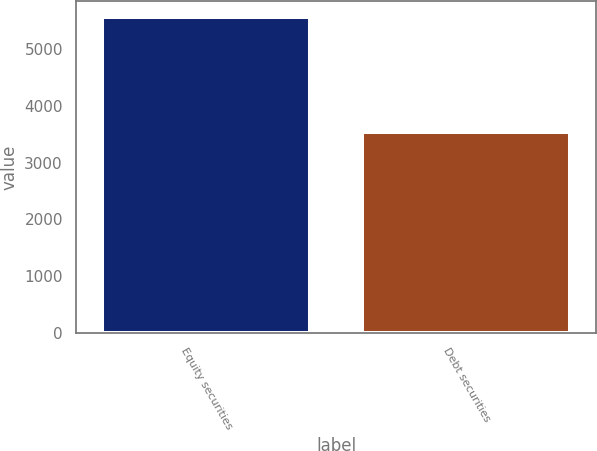Convert chart to OTSL. <chart><loc_0><loc_0><loc_500><loc_500><bar_chart><fcel>Equity securities<fcel>Debt securities<nl><fcel>5565<fcel>3545<nl></chart> 